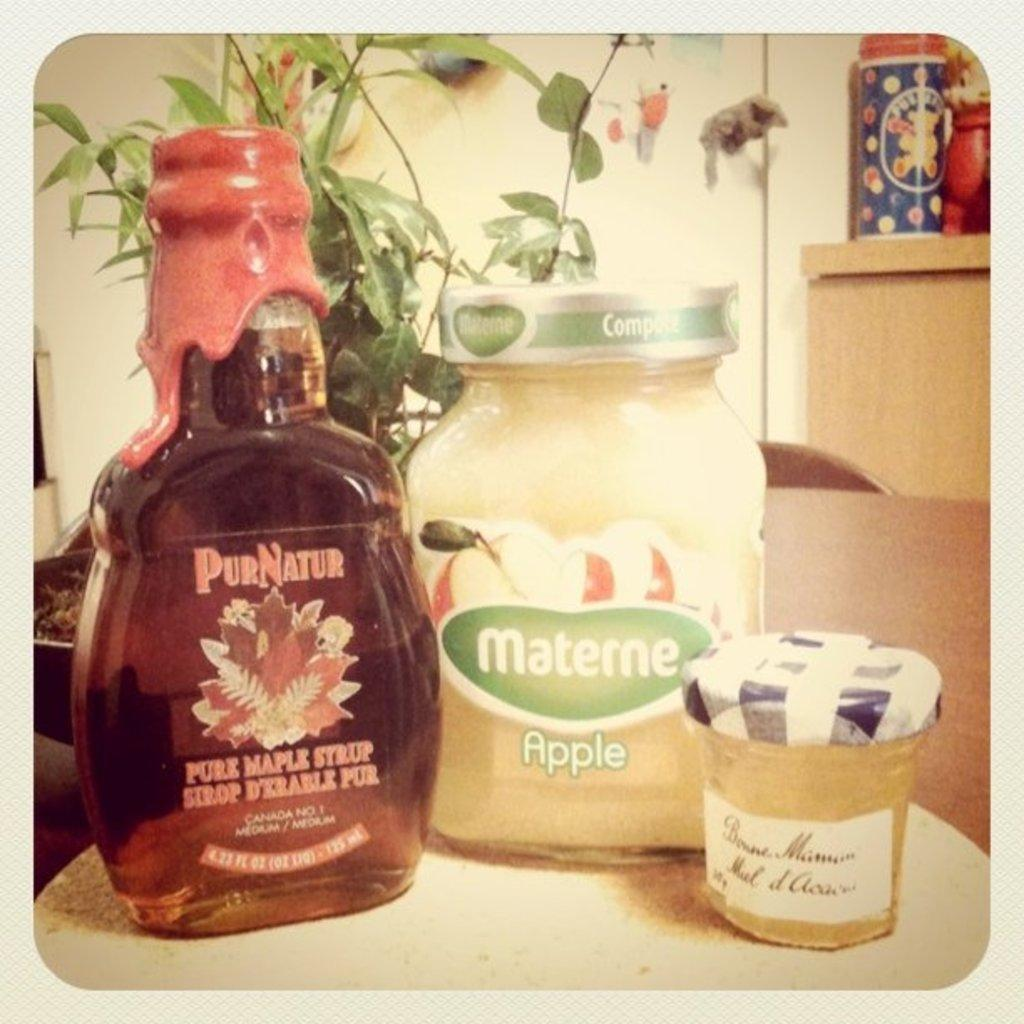What type of structure can be seen in the image? There is a wall in the image. What type of living organism is present in the image? There is a plant in the image. What type of furniture is in the image? There is a table in the image. What items are on the table in the image? There is a bottle, a glass, and a box on the table in the image. How many birds are perched on the wall in the image? There are no birds present in the image. Can you describe the kiss between the two people in the image? There are no people or kisses depicted in the image. 